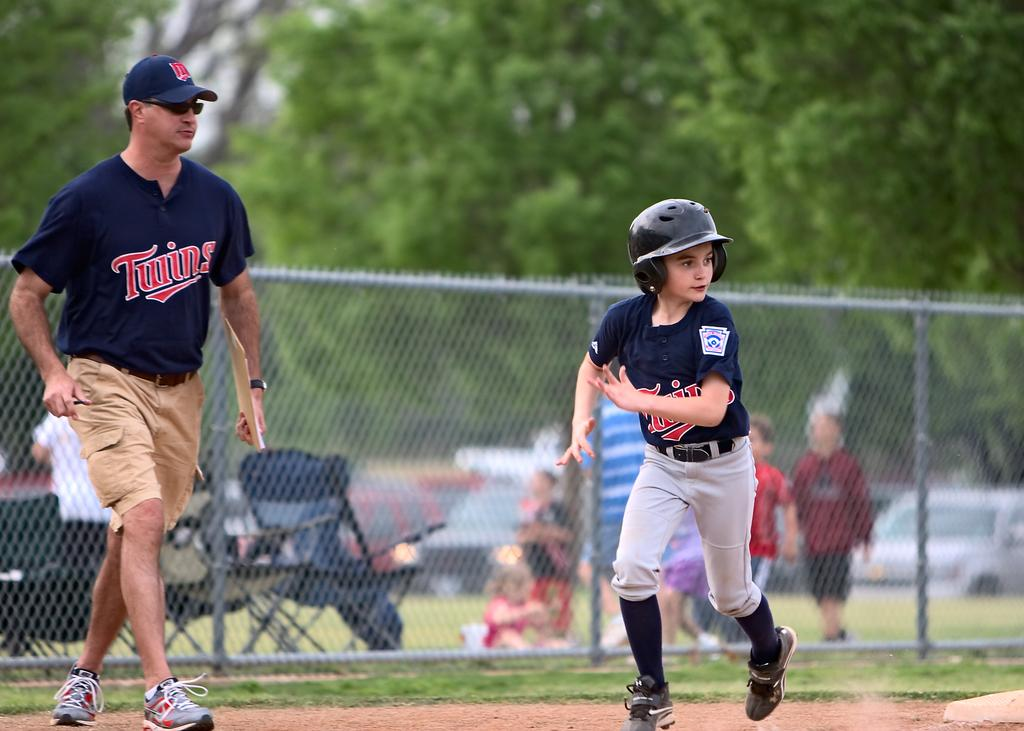<image>
Present a compact description of the photo's key features. A player for the Twins team rounds the base and heads for home. 